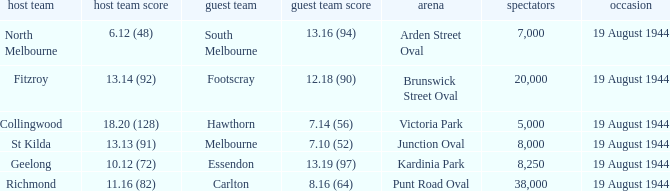What is Fitzroy's Home team Crowd? 20000.0. 